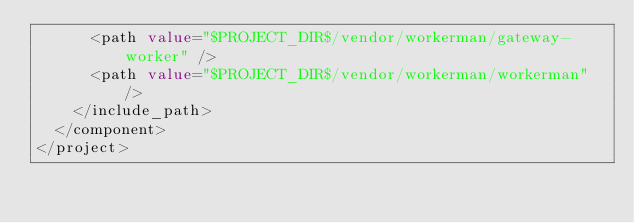<code> <loc_0><loc_0><loc_500><loc_500><_XML_>      <path value="$PROJECT_DIR$/vendor/workerman/gateway-worker" />
      <path value="$PROJECT_DIR$/vendor/workerman/workerman" />
    </include_path>
  </component>
</project></code> 